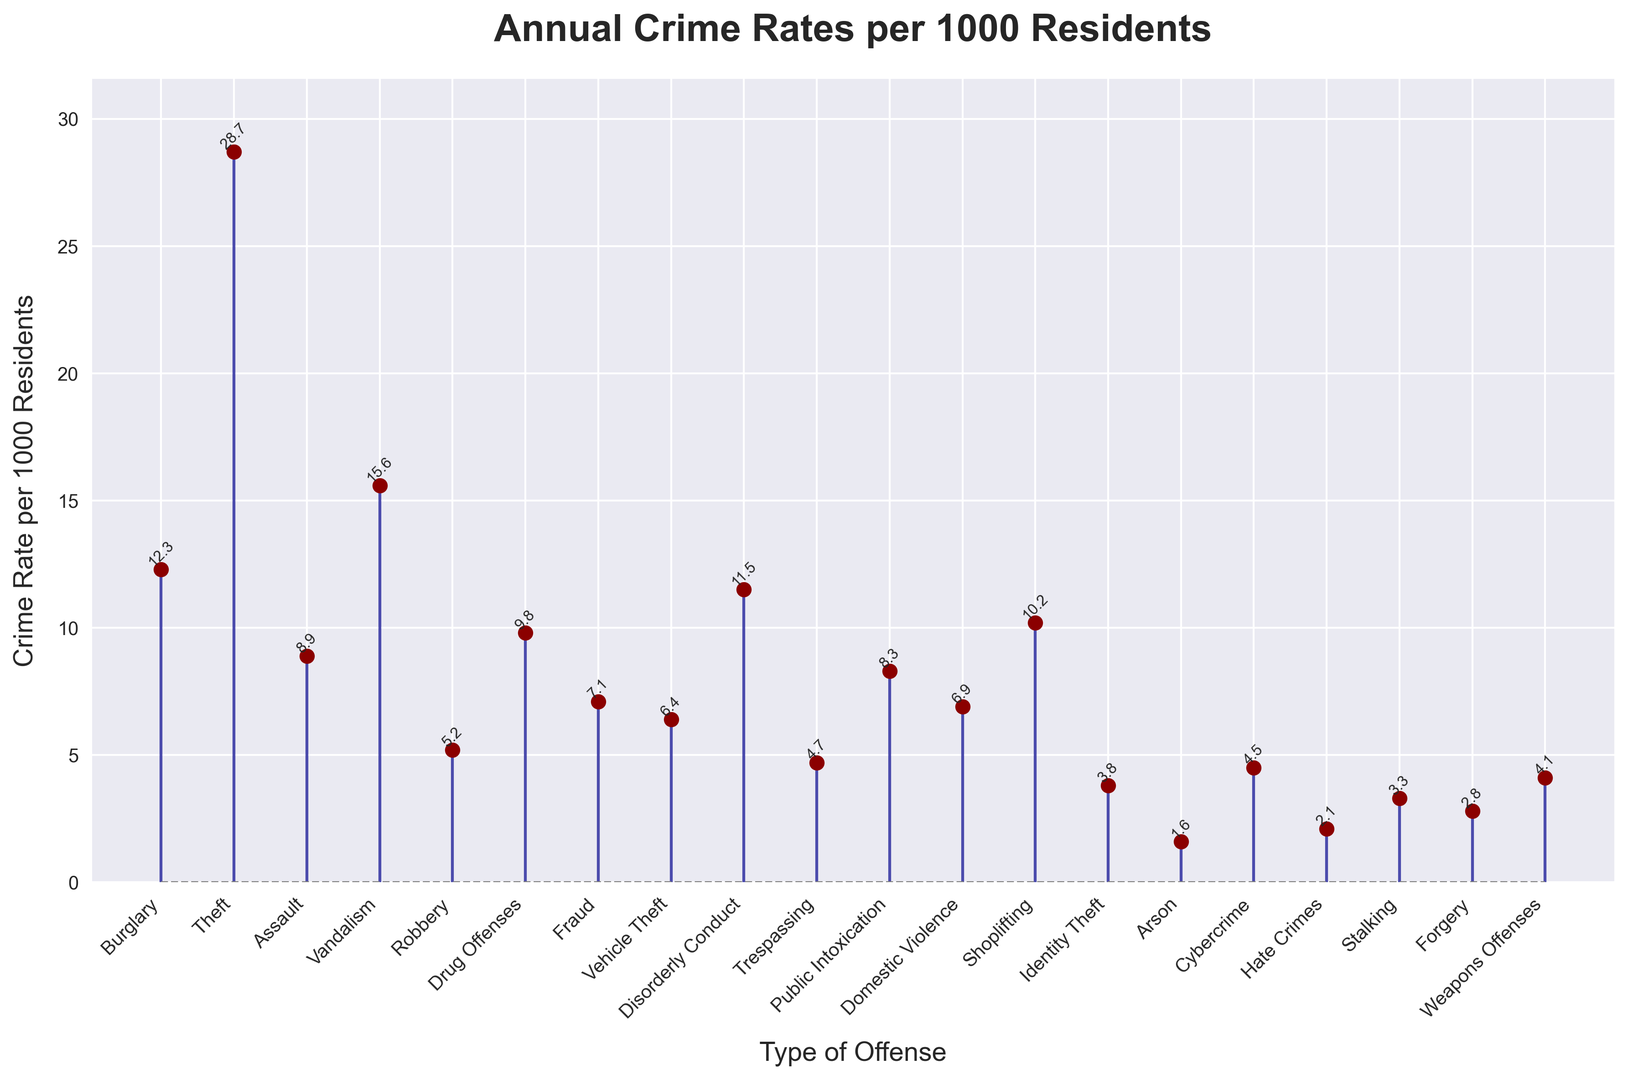Which type of offense has the highest crime rate per 1000 residents? The stem plot shows the crime rates for each type of offense. By visually inspecting the height of the markers, the offense with the highest rate is Theft.
Answer: Theft What is the difference in crime rates between Burglary and Robbery? From the plot, the crime rate for Burglary is 12.3 per 1000 residents, and for Robbery, it is 5.2 per 1000 residents. The difference can be calculated as 12.3 - 5.2.
Answer: 7.1 Which offense has a lower crime rate: Cybercrime or Weapons Offenses? By looking at the heights of the markers, Cybercrime has a rate of 4.5, and Weapons Offenses have a rate of 4.1. Therefore, Weapons Offenses have a lower rate.
Answer: Weapons Offenses How many types of offenses have a crime rate higher than 10 per 1000 residents? The offenses with rates higher than 10 per 1000 residents are Burglary, Theft, Vandalism, Disorderly Conduct, and Shoplifting. Counting these offenses, we get 5.
Answer: 5 What's the combined crime rate for Assault, Drug Offenses, and Public Intoxication? The rates for Assault, Drug Offenses, and Public Intoxication are 8.9, 9.8, and 8.3 respectively. Adding these values gives us 8.9 + 9.8 + 8.3.
Answer: 27 Which offense has a crime rate closest to the median value of all the data points shown? First, we list crime rates in ascending order: 1.6, 2.1, 2.8, 3.3, 3.8, 4.1, 4.5, 4.7, 5.2, 6.4, 6.9, 7.1, 8.3, 8.9, 9.8, 10.2, 11.5, 12.3, 15.6, 28.7. The median is between the 10th and 11th values: (6.4 + 6.9)/2 = 6.65. The closest is Disorderly Conduct with 6.4.
Answer: Disorderly Conduct Which three offenses have the lowest crime rates? By visually inspecting the markers, the three shortest markers correspond to the offenses with the lowest crime rates: Arson (1.6), Hate Crimes (2.1), and Forgery (2.8).
Answer: Arson, Hate Crimes, Forgery Is the crime rate for Vandalism greater than the combined crime rate of Public Intoxication and Stalking? The crime rate for Vandalism is 15.6. The combined rate for Public Intoxication and Stalking is 8.3 + 3.3 = 11.6. Since 15.6 is greater than 11.6, the answer is yes.
Answer: Yes 